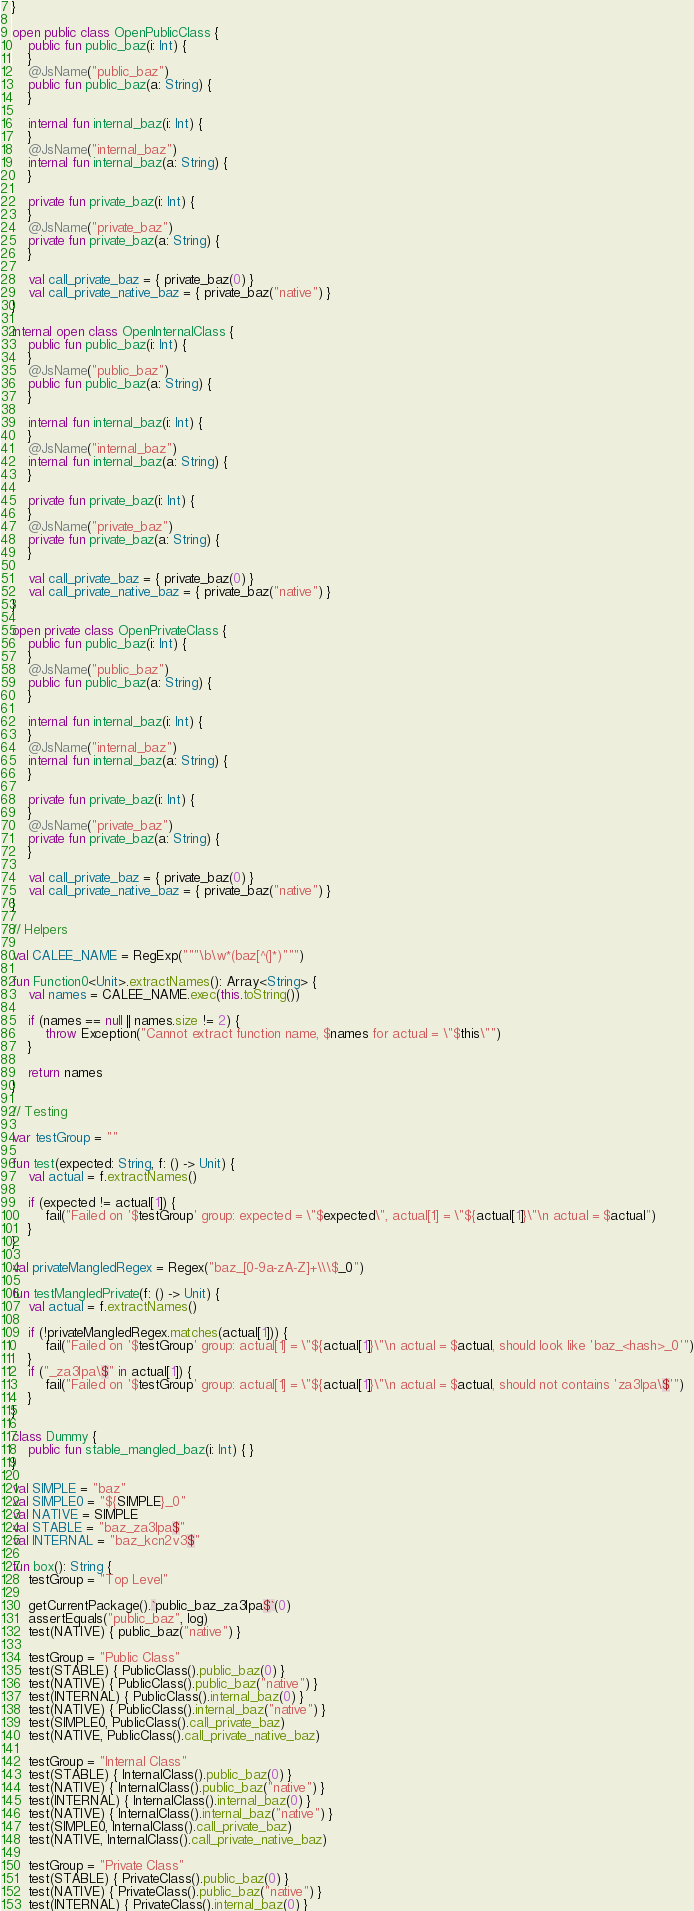Convert code to text. <code><loc_0><loc_0><loc_500><loc_500><_Kotlin_>}

open public class OpenPublicClass {
    public fun public_baz(i: Int) {
    }
    @JsName("public_baz")
    public fun public_baz(a: String) {
    }

    internal fun internal_baz(i: Int) {
    }
    @JsName("internal_baz")
    internal fun internal_baz(a: String) {
    }

    private fun private_baz(i: Int) {
    }
    @JsName("private_baz")
    private fun private_baz(a: String) {
    }

    val call_private_baz = { private_baz(0) }
    val call_private_native_baz = { private_baz("native") }
}

internal open class OpenInternalClass {
    public fun public_baz(i: Int) {
    }
    @JsName("public_baz")
    public fun public_baz(a: String) {
    }

    internal fun internal_baz(i: Int) {
    }
    @JsName("internal_baz")
    internal fun internal_baz(a: String) {
    }

    private fun private_baz(i: Int) {
    }
    @JsName("private_baz")
    private fun private_baz(a: String) {
    }

    val call_private_baz = { private_baz(0) }
    val call_private_native_baz = { private_baz("native") }
}

open private class OpenPrivateClass {
    public fun public_baz(i: Int) {
    }
    @JsName("public_baz")
    public fun public_baz(a: String) {
    }

    internal fun internal_baz(i: Int) {
    }
    @JsName("internal_baz")
    internal fun internal_baz(a: String) {
    }

    private fun private_baz(i: Int) {
    }
    @JsName("private_baz")
    private fun private_baz(a: String) {
    }

    val call_private_baz = { private_baz(0) }
    val call_private_native_baz = { private_baz("native") }
}

// Helpers

val CALEE_NAME = RegExp("""\b\w*(baz[^(]*)""")

fun Function0<Unit>.extractNames(): Array<String> {
    val names = CALEE_NAME.exec(this.toString())

    if (names == null || names.size != 2) {
        throw Exception("Cannot extract function name, $names for actual = \"$this\"")
    }

    return names
}

// Testing

var testGroup = ""

fun test(expected: String, f: () -> Unit) {
    val actual = f.extractNames()

    if (expected != actual[1]) {
        fail("Failed on '$testGroup' group: expected = \"$expected\", actual[1] = \"${actual[1]}\"\n actual = $actual")
    }
}

val privateMangledRegex = Regex("baz_[0-9a-zA-Z]+\\\$_0")

fun testMangledPrivate(f: () -> Unit) {
    val actual = f.extractNames()

    if (!privateMangledRegex.matches(actual[1])) {
        fail("Failed on '$testGroup' group: actual[1] = \"${actual[1]}\"\n actual = $actual, should look like 'baz_<hash>_0'")
    }
    if ("_za3lpa\$" in actual[1]) {
        fail("Failed on '$testGroup' group: actual[1] = \"${actual[1]}\"\n actual = $actual, should not contains 'za3lpa\$'")
    }
}

class Dummy {
    public fun stable_mangled_baz(i: Int) { }
}

val SIMPLE = "baz"
val SIMPLE0 = "${SIMPLE}_0"
val NATIVE = SIMPLE
val STABLE = "baz_za3lpa$"
val INTERNAL = "baz_kcn2v3$"

fun box(): String {
    testGroup = "Top Level"

    getCurrentPackage().`public_baz_za3lpa$`(0)
    assertEquals("public_baz", log)
    test(NATIVE) { public_baz("native") }

    testGroup = "Public Class"
    test(STABLE) { PublicClass().public_baz(0) }
    test(NATIVE) { PublicClass().public_baz("native") }
    test(INTERNAL) { PublicClass().internal_baz(0) }
    test(NATIVE) { PublicClass().internal_baz("native") }
    test(SIMPLE0, PublicClass().call_private_baz)
    test(NATIVE, PublicClass().call_private_native_baz)

    testGroup = "Internal Class"
    test(STABLE) { InternalClass().public_baz(0) }
    test(NATIVE) { InternalClass().public_baz("native") }
    test(INTERNAL) { InternalClass().internal_baz(0) }
    test(NATIVE) { InternalClass().internal_baz("native") }
    test(SIMPLE0, InternalClass().call_private_baz)
    test(NATIVE, InternalClass().call_private_native_baz)

    testGroup = "Private Class"
    test(STABLE) { PrivateClass().public_baz(0) }
    test(NATIVE) { PrivateClass().public_baz("native") }
    test(INTERNAL) { PrivateClass().internal_baz(0) }</code> 